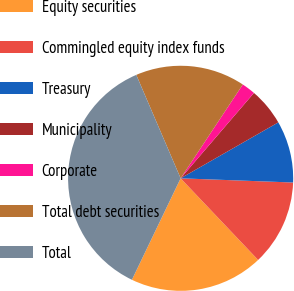<chart> <loc_0><loc_0><loc_500><loc_500><pie_chart><fcel>Equity securities<fcel>Commingled equity index funds<fcel>Treasury<fcel>Municipality<fcel>Corporate<fcel>Total debt securities<fcel>Total<nl><fcel>19.21%<fcel>12.32%<fcel>8.87%<fcel>5.43%<fcel>1.98%<fcel>15.76%<fcel>36.43%<nl></chart> 